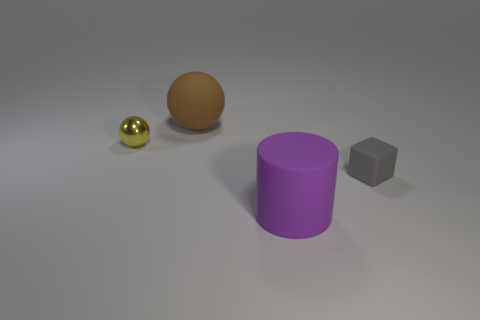Do the matte block and the matte object that is on the left side of the big purple object have the same size?
Your response must be concise. No. What number of other cylinders have the same material as the large purple cylinder?
Offer a very short reply. 0. Is the size of the brown sphere the same as the yellow metallic ball?
Offer a very short reply. No. Is there anything else that has the same color as the large ball?
Ensure brevity in your answer.  No. What shape is the matte object that is behind the cylinder and in front of the yellow object?
Provide a succinct answer. Cube. There is a matte thing right of the purple matte cylinder; what is its size?
Your response must be concise. Small. How many metal things are in front of the ball that is to the right of the small object that is to the left of the tiny matte thing?
Provide a short and direct response. 1. There is a rubber ball; are there any rubber spheres behind it?
Make the answer very short. No. How many other objects are the same size as the rubber ball?
Provide a succinct answer. 1. What material is the thing that is to the left of the large matte cylinder and on the right side of the yellow thing?
Ensure brevity in your answer.  Rubber. 